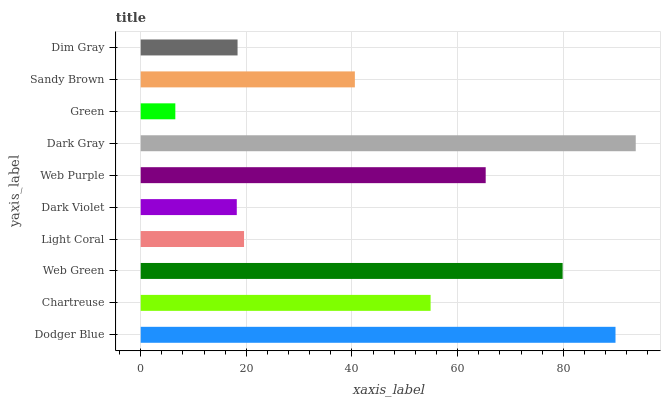Is Green the minimum?
Answer yes or no. Yes. Is Dark Gray the maximum?
Answer yes or no. Yes. Is Chartreuse the minimum?
Answer yes or no. No. Is Chartreuse the maximum?
Answer yes or no. No. Is Dodger Blue greater than Chartreuse?
Answer yes or no. Yes. Is Chartreuse less than Dodger Blue?
Answer yes or no. Yes. Is Chartreuse greater than Dodger Blue?
Answer yes or no. No. Is Dodger Blue less than Chartreuse?
Answer yes or no. No. Is Chartreuse the high median?
Answer yes or no. Yes. Is Sandy Brown the low median?
Answer yes or no. Yes. Is Dark Gray the high median?
Answer yes or no. No. Is Dodger Blue the low median?
Answer yes or no. No. 